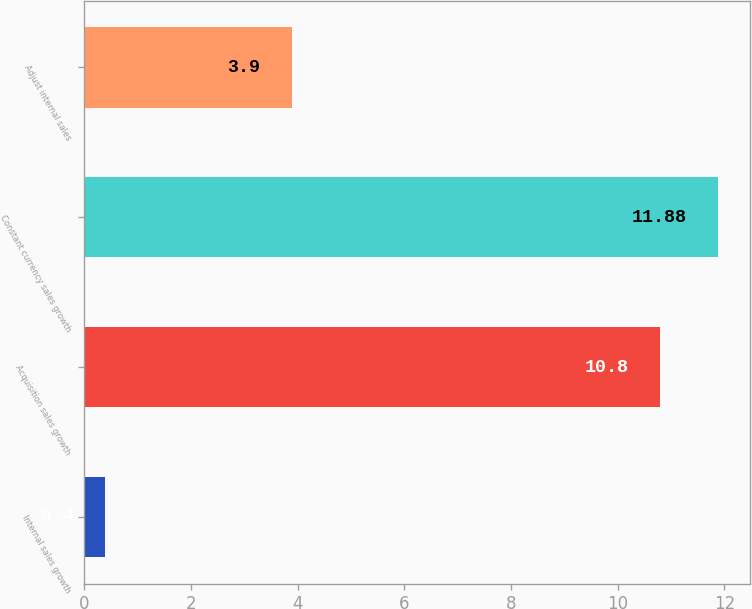<chart> <loc_0><loc_0><loc_500><loc_500><bar_chart><fcel>Internal sales growth<fcel>Acquisition sales growth<fcel>Constant currency sales growth<fcel>Adjust internal sales<nl><fcel>0.4<fcel>10.8<fcel>11.88<fcel>3.9<nl></chart> 